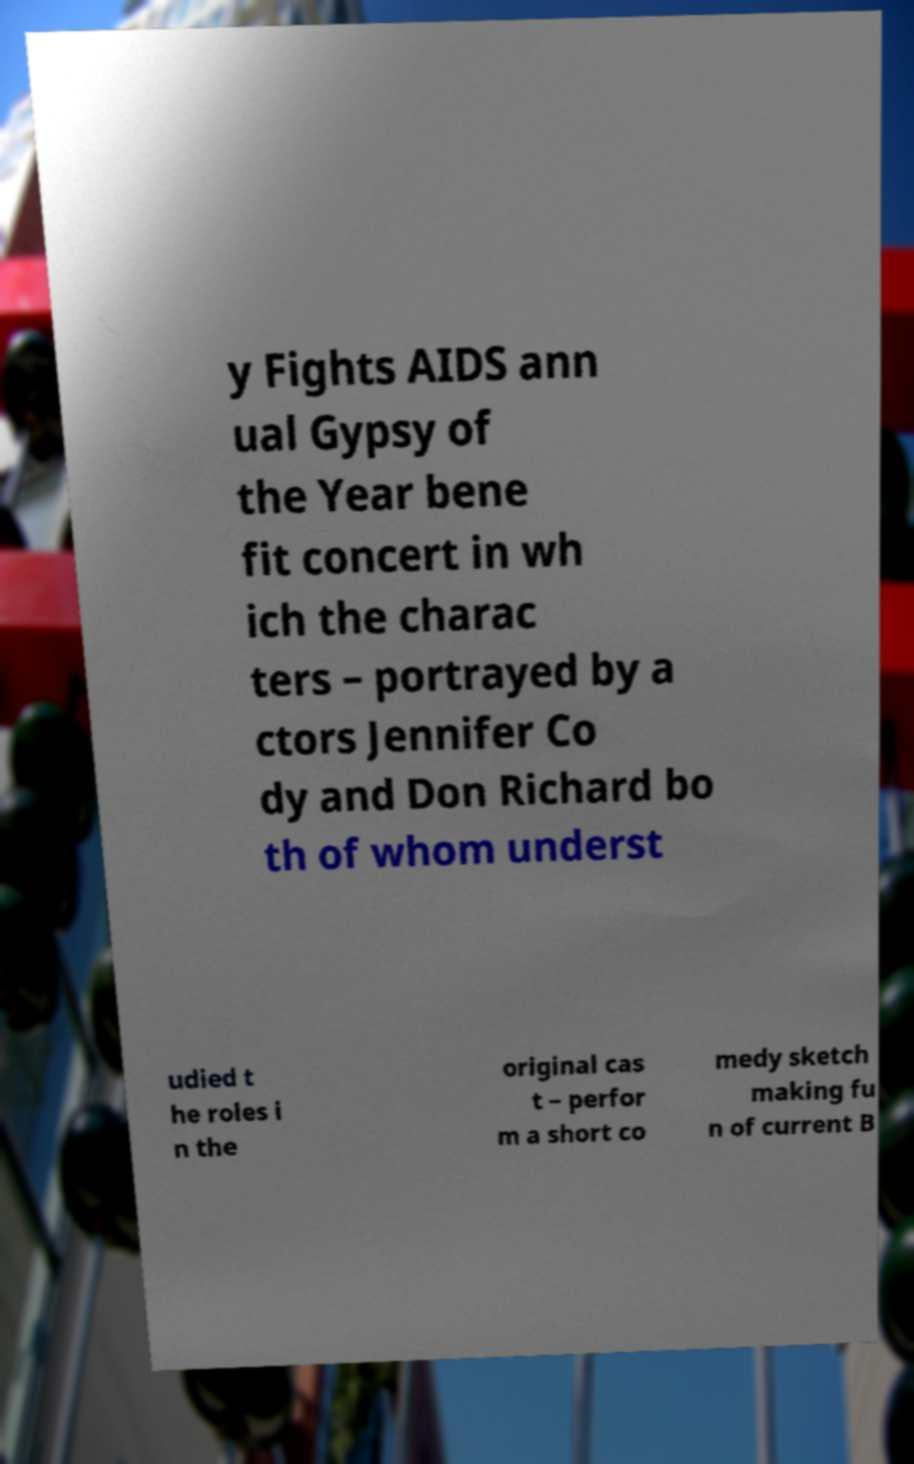Can you accurately transcribe the text from the provided image for me? y Fights AIDS ann ual Gypsy of the Year bene fit concert in wh ich the charac ters – portrayed by a ctors Jennifer Co dy and Don Richard bo th of whom underst udied t he roles i n the original cas t – perfor m a short co medy sketch making fu n of current B 